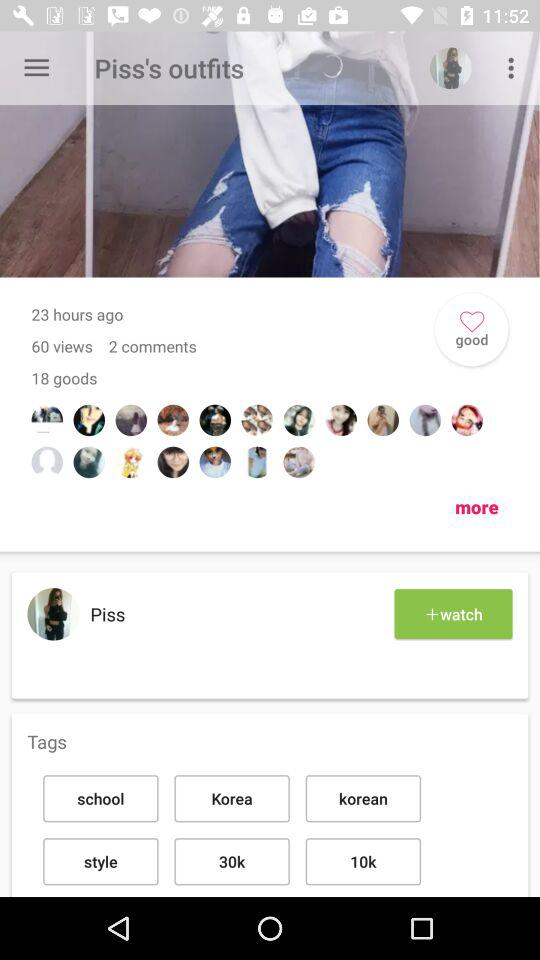How many views are there for "Piss's outfits"? There are 60 views for "Piss's outfits". 